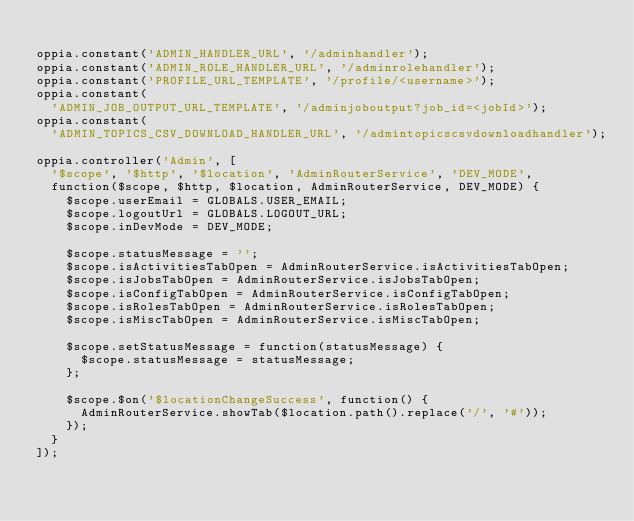<code> <loc_0><loc_0><loc_500><loc_500><_JavaScript_>
oppia.constant('ADMIN_HANDLER_URL', '/adminhandler');
oppia.constant('ADMIN_ROLE_HANDLER_URL', '/adminrolehandler');
oppia.constant('PROFILE_URL_TEMPLATE', '/profile/<username>');
oppia.constant(
  'ADMIN_JOB_OUTPUT_URL_TEMPLATE', '/adminjoboutput?job_id=<jobId>');
oppia.constant(
  'ADMIN_TOPICS_CSV_DOWNLOAD_HANDLER_URL', '/admintopicscsvdownloadhandler');

oppia.controller('Admin', [
  '$scope', '$http', '$location', 'AdminRouterService', 'DEV_MODE',
  function($scope, $http, $location, AdminRouterService, DEV_MODE) {
    $scope.userEmail = GLOBALS.USER_EMAIL;
    $scope.logoutUrl = GLOBALS.LOGOUT_URL;
    $scope.inDevMode = DEV_MODE;

    $scope.statusMessage = '';
    $scope.isActivitiesTabOpen = AdminRouterService.isActivitiesTabOpen;
    $scope.isJobsTabOpen = AdminRouterService.isJobsTabOpen;
    $scope.isConfigTabOpen = AdminRouterService.isConfigTabOpen;
    $scope.isRolesTabOpen = AdminRouterService.isRolesTabOpen;
    $scope.isMiscTabOpen = AdminRouterService.isMiscTabOpen;

    $scope.setStatusMessage = function(statusMessage) {
      $scope.statusMessage = statusMessage;
    };

    $scope.$on('$locationChangeSuccess', function() {
      AdminRouterService.showTab($location.path().replace('/', '#'));
    });
  }
]);
</code> 